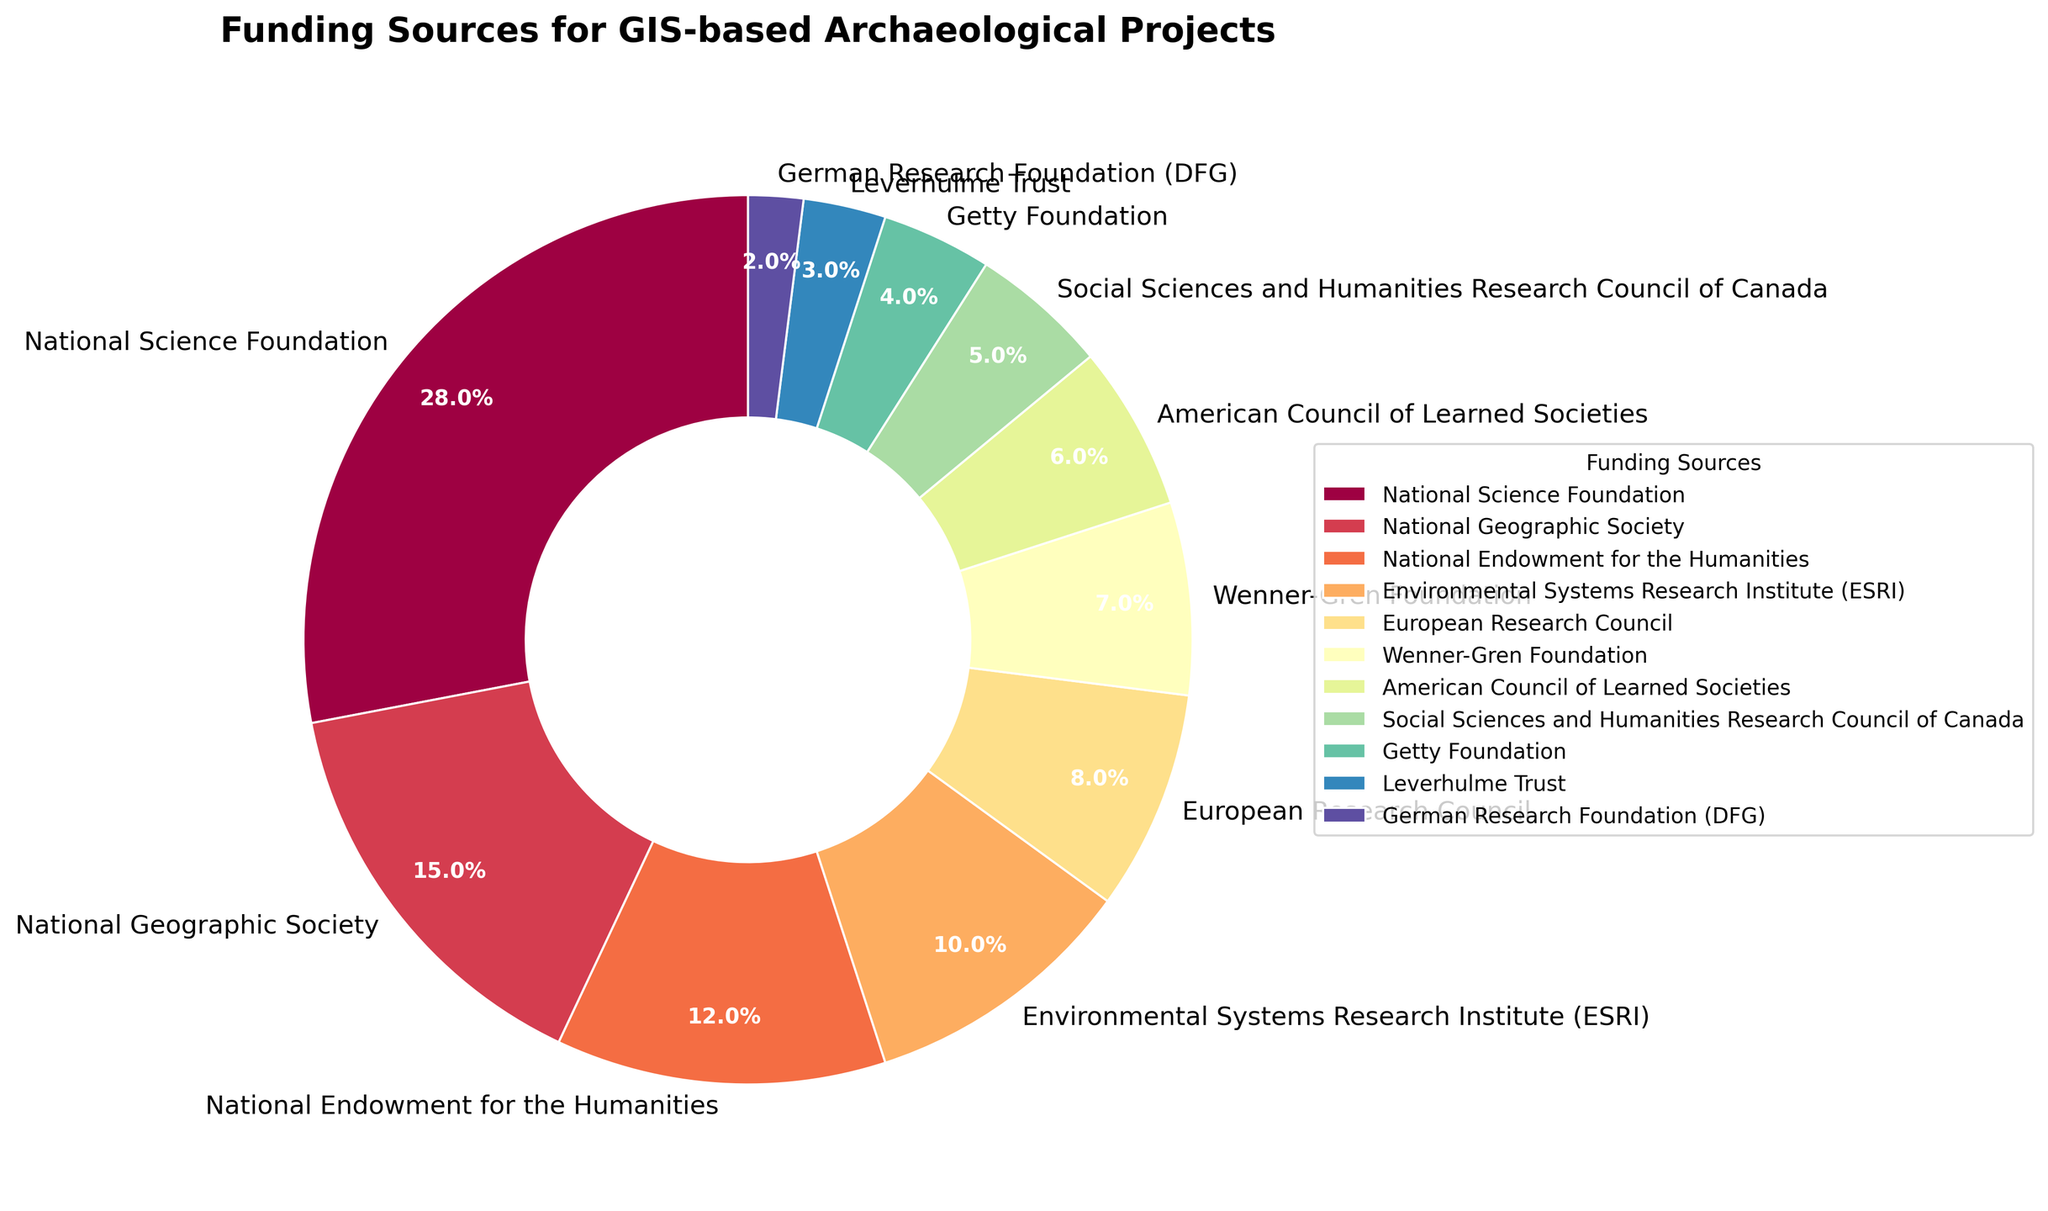Which funding source provides the highest percentage of funding? The National Science Foundation has the largest slice in the pie chart, representing 28% of the total funding.
Answer: National Science Foundation Which two funding sources combined provide the same percentage of funding as the National Science Foundation? To match the 28% provided by the National Science Foundation, we can combine the National Geographic Society (15%) and the Wenner-Gren Foundation (7%), which sum up to 22%, or National Geographic Society (15%) and National Endowment for the Humanities (12%), which sum up to 27%. Therefore, we should look for the exact answer by matching the sums: National Geographic Society (15%) + National Endowment for the Humanities (12%) equals 27%, and adding 1% from Getty Foundation adds up to 28%.
Answer: National Geographic Society and National Endowment for the Humanities What is the combined percentage of funding from the Environmental Systems Research Institute (ESRI) and the European Research Council? The percentage from ESRI is 10% and from the European Research Council is 8%. Summing these, 10% + 8% = 18%.
Answer: 18% Which funding source provides more funding: the Leverhulme Trust or the Getty Foundation? The pie chart shows that the Getty Foundation provides 4% while the Leverhulme Trust provides 3%.
Answer: Getty Foundation Which funding source provides the second lowest percentage of funding? Upon examining the pie chart, the German Research Foundation (DFG) is the smallest at 2%, making the Leverhulme Trust at 3% the second lowest.
Answer: Leverhulme Trust 